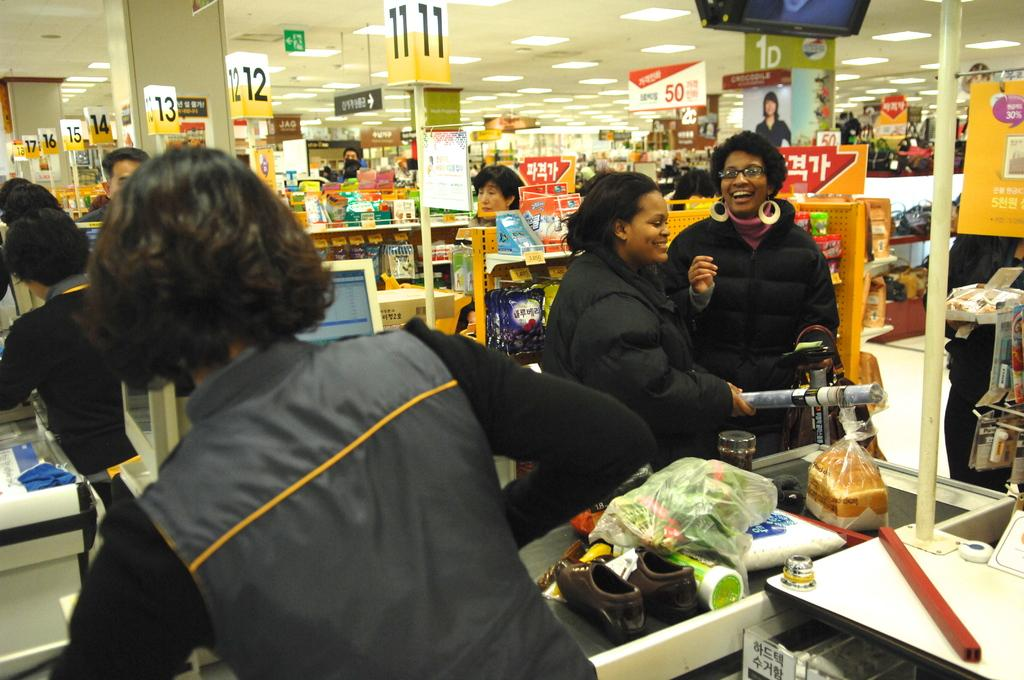<image>
Describe the image concisely. Two women in line near lane 11 are laughing together 